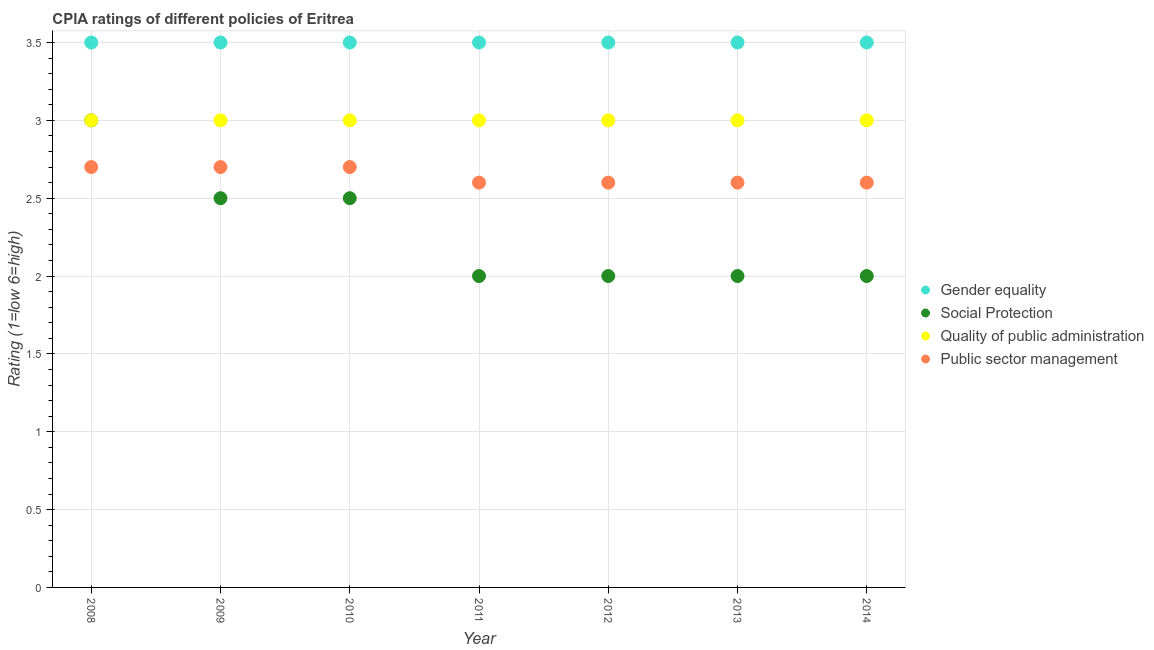How many different coloured dotlines are there?
Give a very brief answer. 4. Across all years, what is the minimum cpia rating of gender equality?
Provide a short and direct response. 3.5. In which year was the cpia rating of gender equality minimum?
Keep it short and to the point. 2008. What is the difference between the cpia rating of quality of public administration in 2013 and that in 2014?
Make the answer very short. 0. What is the average cpia rating of social protection per year?
Keep it short and to the point. 2.29. In the year 2014, what is the difference between the cpia rating of public sector management and cpia rating of social protection?
Provide a short and direct response. 0.6. What is the ratio of the cpia rating of quality of public administration in 2008 to that in 2014?
Offer a terse response. 1. Is the cpia rating of quality of public administration in 2011 less than that in 2013?
Ensure brevity in your answer.  No. Is the difference between the cpia rating of public sector management in 2013 and 2014 greater than the difference between the cpia rating of gender equality in 2013 and 2014?
Give a very brief answer. No. What is the difference between the highest and the lowest cpia rating of public sector management?
Offer a very short reply. 0.1. Is the sum of the cpia rating of quality of public administration in 2009 and 2013 greater than the maximum cpia rating of public sector management across all years?
Make the answer very short. Yes. Is it the case that in every year, the sum of the cpia rating of gender equality and cpia rating of public sector management is greater than the sum of cpia rating of quality of public administration and cpia rating of social protection?
Keep it short and to the point. No. Does the cpia rating of social protection monotonically increase over the years?
Your response must be concise. No. Is the cpia rating of social protection strictly less than the cpia rating of public sector management over the years?
Offer a terse response. No. How many dotlines are there?
Offer a terse response. 4. How many years are there in the graph?
Keep it short and to the point. 7. Are the values on the major ticks of Y-axis written in scientific E-notation?
Provide a succinct answer. No. Does the graph contain grids?
Keep it short and to the point. Yes. What is the title of the graph?
Make the answer very short. CPIA ratings of different policies of Eritrea. Does "Third 20% of population" appear as one of the legend labels in the graph?
Your answer should be compact. No. What is the Rating (1=low 6=high) of Social Protection in 2008?
Offer a very short reply. 3. What is the Rating (1=low 6=high) of Public sector management in 2008?
Keep it short and to the point. 2.7. What is the Rating (1=low 6=high) of Gender equality in 2009?
Your response must be concise. 3.5. What is the Rating (1=low 6=high) in Social Protection in 2010?
Give a very brief answer. 2.5. What is the Rating (1=low 6=high) in Quality of public administration in 2010?
Give a very brief answer. 3. What is the Rating (1=low 6=high) of Public sector management in 2010?
Make the answer very short. 2.7. What is the Rating (1=low 6=high) of Social Protection in 2011?
Make the answer very short. 2. What is the Rating (1=low 6=high) of Quality of public administration in 2011?
Keep it short and to the point. 3. What is the Rating (1=low 6=high) in Public sector management in 2011?
Make the answer very short. 2.6. What is the Rating (1=low 6=high) of Gender equality in 2012?
Give a very brief answer. 3.5. What is the Rating (1=low 6=high) in Public sector management in 2012?
Keep it short and to the point. 2.6. What is the Rating (1=low 6=high) of Gender equality in 2013?
Your answer should be compact. 3.5. What is the Rating (1=low 6=high) of Public sector management in 2014?
Offer a terse response. 2.6. Across all years, what is the maximum Rating (1=low 6=high) of Social Protection?
Your answer should be compact. 3. Across all years, what is the maximum Rating (1=low 6=high) in Quality of public administration?
Your answer should be compact. 3. Across all years, what is the maximum Rating (1=low 6=high) in Public sector management?
Make the answer very short. 2.7. Across all years, what is the minimum Rating (1=low 6=high) in Gender equality?
Offer a very short reply. 3.5. What is the difference between the Rating (1=low 6=high) in Gender equality in 2008 and that in 2009?
Ensure brevity in your answer.  0. What is the difference between the Rating (1=low 6=high) in Social Protection in 2008 and that in 2010?
Your response must be concise. 0.5. What is the difference between the Rating (1=low 6=high) in Public sector management in 2008 and that in 2010?
Your response must be concise. 0. What is the difference between the Rating (1=low 6=high) in Social Protection in 2008 and that in 2011?
Ensure brevity in your answer.  1. What is the difference between the Rating (1=low 6=high) in Quality of public administration in 2008 and that in 2012?
Offer a very short reply. 0. What is the difference between the Rating (1=low 6=high) of Gender equality in 2008 and that in 2013?
Ensure brevity in your answer.  0. What is the difference between the Rating (1=low 6=high) in Gender equality in 2008 and that in 2014?
Offer a terse response. 0. What is the difference between the Rating (1=low 6=high) in Social Protection in 2008 and that in 2014?
Give a very brief answer. 1. What is the difference between the Rating (1=low 6=high) in Quality of public administration in 2008 and that in 2014?
Give a very brief answer. 0. What is the difference between the Rating (1=low 6=high) of Public sector management in 2008 and that in 2014?
Keep it short and to the point. 0.1. What is the difference between the Rating (1=low 6=high) of Gender equality in 2009 and that in 2010?
Offer a terse response. 0. What is the difference between the Rating (1=low 6=high) in Social Protection in 2009 and that in 2010?
Your answer should be very brief. 0. What is the difference between the Rating (1=low 6=high) of Gender equality in 2009 and that in 2011?
Ensure brevity in your answer.  0. What is the difference between the Rating (1=low 6=high) of Social Protection in 2009 and that in 2011?
Make the answer very short. 0.5. What is the difference between the Rating (1=low 6=high) in Quality of public administration in 2009 and that in 2011?
Your response must be concise. 0. What is the difference between the Rating (1=low 6=high) in Gender equality in 2009 and that in 2012?
Give a very brief answer. 0. What is the difference between the Rating (1=low 6=high) of Social Protection in 2009 and that in 2012?
Offer a very short reply. 0.5. What is the difference between the Rating (1=low 6=high) in Social Protection in 2009 and that in 2013?
Make the answer very short. 0.5. What is the difference between the Rating (1=low 6=high) of Quality of public administration in 2009 and that in 2013?
Offer a terse response. 0. What is the difference between the Rating (1=low 6=high) of Public sector management in 2009 and that in 2013?
Ensure brevity in your answer.  0.1. What is the difference between the Rating (1=low 6=high) in Public sector management in 2009 and that in 2014?
Provide a succinct answer. 0.1. What is the difference between the Rating (1=low 6=high) of Quality of public administration in 2010 and that in 2011?
Offer a very short reply. 0. What is the difference between the Rating (1=low 6=high) in Public sector management in 2010 and that in 2011?
Your answer should be very brief. 0.1. What is the difference between the Rating (1=low 6=high) of Gender equality in 2010 and that in 2012?
Make the answer very short. 0. What is the difference between the Rating (1=low 6=high) in Public sector management in 2010 and that in 2012?
Offer a terse response. 0.1. What is the difference between the Rating (1=low 6=high) of Gender equality in 2010 and that in 2013?
Ensure brevity in your answer.  0. What is the difference between the Rating (1=low 6=high) in Social Protection in 2010 and that in 2014?
Provide a succinct answer. 0.5. What is the difference between the Rating (1=low 6=high) in Quality of public administration in 2010 and that in 2014?
Provide a succinct answer. 0. What is the difference between the Rating (1=low 6=high) in Quality of public administration in 2011 and that in 2012?
Offer a terse response. 0. What is the difference between the Rating (1=low 6=high) in Public sector management in 2011 and that in 2012?
Your answer should be compact. 0. What is the difference between the Rating (1=low 6=high) of Quality of public administration in 2011 and that in 2014?
Your answer should be very brief. 0. What is the difference between the Rating (1=low 6=high) of Public sector management in 2011 and that in 2014?
Make the answer very short. 0. What is the difference between the Rating (1=low 6=high) of Gender equality in 2012 and that in 2013?
Give a very brief answer. 0. What is the difference between the Rating (1=low 6=high) of Social Protection in 2012 and that in 2013?
Keep it short and to the point. 0. What is the difference between the Rating (1=low 6=high) of Public sector management in 2012 and that in 2013?
Provide a short and direct response. 0. What is the difference between the Rating (1=low 6=high) of Gender equality in 2012 and that in 2014?
Your answer should be very brief. 0. What is the difference between the Rating (1=low 6=high) in Public sector management in 2012 and that in 2014?
Offer a terse response. 0. What is the difference between the Rating (1=low 6=high) in Gender equality in 2013 and that in 2014?
Keep it short and to the point. 0. What is the difference between the Rating (1=low 6=high) in Quality of public administration in 2013 and that in 2014?
Keep it short and to the point. 0. What is the difference between the Rating (1=low 6=high) of Gender equality in 2008 and the Rating (1=low 6=high) of Social Protection in 2009?
Your answer should be compact. 1. What is the difference between the Rating (1=low 6=high) in Gender equality in 2008 and the Rating (1=low 6=high) in Quality of public administration in 2009?
Ensure brevity in your answer.  0.5. What is the difference between the Rating (1=low 6=high) of Gender equality in 2008 and the Rating (1=low 6=high) of Public sector management in 2009?
Your response must be concise. 0.8. What is the difference between the Rating (1=low 6=high) in Social Protection in 2008 and the Rating (1=low 6=high) in Quality of public administration in 2009?
Your answer should be very brief. 0. What is the difference between the Rating (1=low 6=high) in Gender equality in 2008 and the Rating (1=low 6=high) in Social Protection in 2010?
Keep it short and to the point. 1. What is the difference between the Rating (1=low 6=high) of Social Protection in 2008 and the Rating (1=low 6=high) of Quality of public administration in 2010?
Offer a very short reply. 0. What is the difference between the Rating (1=low 6=high) in Social Protection in 2008 and the Rating (1=low 6=high) in Public sector management in 2010?
Provide a succinct answer. 0.3. What is the difference between the Rating (1=low 6=high) in Gender equality in 2008 and the Rating (1=low 6=high) in Social Protection in 2011?
Your answer should be compact. 1.5. What is the difference between the Rating (1=low 6=high) in Social Protection in 2008 and the Rating (1=low 6=high) in Quality of public administration in 2011?
Ensure brevity in your answer.  0. What is the difference between the Rating (1=low 6=high) of Gender equality in 2008 and the Rating (1=low 6=high) of Quality of public administration in 2012?
Provide a short and direct response. 0.5. What is the difference between the Rating (1=low 6=high) in Gender equality in 2008 and the Rating (1=low 6=high) in Public sector management in 2012?
Ensure brevity in your answer.  0.9. What is the difference between the Rating (1=low 6=high) in Social Protection in 2008 and the Rating (1=low 6=high) in Quality of public administration in 2012?
Keep it short and to the point. 0. What is the difference between the Rating (1=low 6=high) in Gender equality in 2008 and the Rating (1=low 6=high) in Public sector management in 2013?
Your answer should be very brief. 0.9. What is the difference between the Rating (1=low 6=high) in Social Protection in 2008 and the Rating (1=low 6=high) in Quality of public administration in 2013?
Provide a short and direct response. 0. What is the difference between the Rating (1=low 6=high) of Quality of public administration in 2008 and the Rating (1=low 6=high) of Public sector management in 2013?
Provide a short and direct response. 0.4. What is the difference between the Rating (1=low 6=high) of Gender equality in 2008 and the Rating (1=low 6=high) of Social Protection in 2014?
Provide a short and direct response. 1.5. What is the difference between the Rating (1=low 6=high) in Social Protection in 2008 and the Rating (1=low 6=high) in Public sector management in 2014?
Provide a succinct answer. 0.4. What is the difference between the Rating (1=low 6=high) of Gender equality in 2009 and the Rating (1=low 6=high) of Quality of public administration in 2010?
Offer a terse response. 0.5. What is the difference between the Rating (1=low 6=high) of Gender equality in 2009 and the Rating (1=low 6=high) of Public sector management in 2010?
Your response must be concise. 0.8. What is the difference between the Rating (1=low 6=high) in Social Protection in 2009 and the Rating (1=low 6=high) in Quality of public administration in 2010?
Offer a very short reply. -0.5. What is the difference between the Rating (1=low 6=high) of Social Protection in 2009 and the Rating (1=low 6=high) of Public sector management in 2010?
Offer a very short reply. -0.2. What is the difference between the Rating (1=low 6=high) of Quality of public administration in 2009 and the Rating (1=low 6=high) of Public sector management in 2010?
Your answer should be compact. 0.3. What is the difference between the Rating (1=low 6=high) in Gender equality in 2009 and the Rating (1=low 6=high) in Social Protection in 2011?
Your answer should be compact. 1.5. What is the difference between the Rating (1=low 6=high) of Social Protection in 2009 and the Rating (1=low 6=high) of Quality of public administration in 2011?
Your answer should be compact. -0.5. What is the difference between the Rating (1=low 6=high) in Social Protection in 2009 and the Rating (1=low 6=high) in Public sector management in 2011?
Your answer should be compact. -0.1. What is the difference between the Rating (1=low 6=high) in Gender equality in 2009 and the Rating (1=low 6=high) in Public sector management in 2012?
Your response must be concise. 0.9. What is the difference between the Rating (1=low 6=high) in Social Protection in 2009 and the Rating (1=low 6=high) in Public sector management in 2012?
Offer a very short reply. -0.1. What is the difference between the Rating (1=low 6=high) in Gender equality in 2009 and the Rating (1=low 6=high) in Public sector management in 2013?
Your response must be concise. 0.9. What is the difference between the Rating (1=low 6=high) in Social Protection in 2009 and the Rating (1=low 6=high) in Public sector management in 2013?
Offer a terse response. -0.1. What is the difference between the Rating (1=low 6=high) in Gender equality in 2009 and the Rating (1=low 6=high) in Quality of public administration in 2014?
Your answer should be compact. 0.5. What is the difference between the Rating (1=low 6=high) of Social Protection in 2009 and the Rating (1=low 6=high) of Quality of public administration in 2014?
Keep it short and to the point. -0.5. What is the difference between the Rating (1=low 6=high) in Social Protection in 2009 and the Rating (1=low 6=high) in Public sector management in 2014?
Offer a terse response. -0.1. What is the difference between the Rating (1=low 6=high) in Gender equality in 2010 and the Rating (1=low 6=high) in Social Protection in 2011?
Give a very brief answer. 1.5. What is the difference between the Rating (1=low 6=high) of Social Protection in 2010 and the Rating (1=low 6=high) of Quality of public administration in 2011?
Keep it short and to the point. -0.5. What is the difference between the Rating (1=low 6=high) of Social Protection in 2010 and the Rating (1=low 6=high) of Quality of public administration in 2012?
Ensure brevity in your answer.  -0.5. What is the difference between the Rating (1=low 6=high) of Quality of public administration in 2010 and the Rating (1=low 6=high) of Public sector management in 2012?
Keep it short and to the point. 0.4. What is the difference between the Rating (1=low 6=high) of Gender equality in 2010 and the Rating (1=low 6=high) of Public sector management in 2013?
Your answer should be very brief. 0.9. What is the difference between the Rating (1=low 6=high) of Quality of public administration in 2010 and the Rating (1=low 6=high) of Public sector management in 2013?
Provide a short and direct response. 0.4. What is the difference between the Rating (1=low 6=high) of Gender equality in 2010 and the Rating (1=low 6=high) of Social Protection in 2014?
Your answer should be compact. 1.5. What is the difference between the Rating (1=low 6=high) of Gender equality in 2010 and the Rating (1=low 6=high) of Public sector management in 2014?
Provide a succinct answer. 0.9. What is the difference between the Rating (1=low 6=high) in Gender equality in 2011 and the Rating (1=low 6=high) in Social Protection in 2012?
Keep it short and to the point. 1.5. What is the difference between the Rating (1=low 6=high) in Gender equality in 2011 and the Rating (1=low 6=high) in Quality of public administration in 2012?
Provide a succinct answer. 0.5. What is the difference between the Rating (1=low 6=high) of Gender equality in 2011 and the Rating (1=low 6=high) of Public sector management in 2012?
Offer a very short reply. 0.9. What is the difference between the Rating (1=low 6=high) of Social Protection in 2011 and the Rating (1=low 6=high) of Quality of public administration in 2012?
Your answer should be very brief. -1. What is the difference between the Rating (1=low 6=high) in Gender equality in 2011 and the Rating (1=low 6=high) in Social Protection in 2013?
Give a very brief answer. 1.5. What is the difference between the Rating (1=low 6=high) of Gender equality in 2011 and the Rating (1=low 6=high) of Quality of public administration in 2013?
Give a very brief answer. 0.5. What is the difference between the Rating (1=low 6=high) in Gender equality in 2011 and the Rating (1=low 6=high) in Public sector management in 2013?
Ensure brevity in your answer.  0.9. What is the difference between the Rating (1=low 6=high) of Social Protection in 2011 and the Rating (1=low 6=high) of Quality of public administration in 2013?
Your response must be concise. -1. What is the difference between the Rating (1=low 6=high) of Quality of public administration in 2011 and the Rating (1=low 6=high) of Public sector management in 2013?
Keep it short and to the point. 0.4. What is the difference between the Rating (1=low 6=high) in Gender equality in 2011 and the Rating (1=low 6=high) in Quality of public administration in 2014?
Provide a short and direct response. 0.5. What is the difference between the Rating (1=low 6=high) of Gender equality in 2011 and the Rating (1=low 6=high) of Public sector management in 2014?
Make the answer very short. 0.9. What is the difference between the Rating (1=low 6=high) of Social Protection in 2011 and the Rating (1=low 6=high) of Quality of public administration in 2014?
Ensure brevity in your answer.  -1. What is the difference between the Rating (1=low 6=high) in Gender equality in 2012 and the Rating (1=low 6=high) in Social Protection in 2013?
Provide a short and direct response. 1.5. What is the difference between the Rating (1=low 6=high) in Gender equality in 2012 and the Rating (1=low 6=high) in Quality of public administration in 2013?
Offer a terse response. 0.5. What is the difference between the Rating (1=low 6=high) in Social Protection in 2012 and the Rating (1=low 6=high) in Quality of public administration in 2013?
Give a very brief answer. -1. What is the difference between the Rating (1=low 6=high) in Gender equality in 2012 and the Rating (1=low 6=high) in Public sector management in 2014?
Offer a terse response. 0.9. What is the difference between the Rating (1=low 6=high) in Gender equality in 2013 and the Rating (1=low 6=high) in Social Protection in 2014?
Offer a very short reply. 1.5. What is the difference between the Rating (1=low 6=high) of Gender equality in 2013 and the Rating (1=low 6=high) of Public sector management in 2014?
Your answer should be compact. 0.9. What is the difference between the Rating (1=low 6=high) of Social Protection in 2013 and the Rating (1=low 6=high) of Quality of public administration in 2014?
Your response must be concise. -1. What is the difference between the Rating (1=low 6=high) in Social Protection in 2013 and the Rating (1=low 6=high) in Public sector management in 2014?
Ensure brevity in your answer.  -0.6. What is the average Rating (1=low 6=high) in Gender equality per year?
Make the answer very short. 3.5. What is the average Rating (1=low 6=high) in Social Protection per year?
Provide a short and direct response. 2.29. What is the average Rating (1=low 6=high) in Public sector management per year?
Make the answer very short. 2.64. In the year 2008, what is the difference between the Rating (1=low 6=high) of Gender equality and Rating (1=low 6=high) of Quality of public administration?
Offer a very short reply. 0.5. In the year 2008, what is the difference between the Rating (1=low 6=high) of Social Protection and Rating (1=low 6=high) of Public sector management?
Your response must be concise. 0.3. In the year 2009, what is the difference between the Rating (1=low 6=high) in Social Protection and Rating (1=low 6=high) in Quality of public administration?
Provide a succinct answer. -0.5. In the year 2010, what is the difference between the Rating (1=low 6=high) of Gender equality and Rating (1=low 6=high) of Quality of public administration?
Your answer should be compact. 0.5. In the year 2010, what is the difference between the Rating (1=low 6=high) of Gender equality and Rating (1=low 6=high) of Public sector management?
Provide a succinct answer. 0.8. In the year 2010, what is the difference between the Rating (1=low 6=high) in Quality of public administration and Rating (1=low 6=high) in Public sector management?
Make the answer very short. 0.3. In the year 2011, what is the difference between the Rating (1=low 6=high) of Social Protection and Rating (1=low 6=high) of Public sector management?
Keep it short and to the point. -0.6. In the year 2011, what is the difference between the Rating (1=low 6=high) in Quality of public administration and Rating (1=low 6=high) in Public sector management?
Offer a very short reply. 0.4. In the year 2012, what is the difference between the Rating (1=low 6=high) of Gender equality and Rating (1=low 6=high) of Quality of public administration?
Keep it short and to the point. 0.5. In the year 2012, what is the difference between the Rating (1=low 6=high) in Social Protection and Rating (1=low 6=high) in Public sector management?
Offer a terse response. -0.6. In the year 2013, what is the difference between the Rating (1=low 6=high) in Gender equality and Rating (1=low 6=high) in Social Protection?
Keep it short and to the point. 1.5. In the year 2013, what is the difference between the Rating (1=low 6=high) in Gender equality and Rating (1=low 6=high) in Public sector management?
Make the answer very short. 0.9. In the year 2013, what is the difference between the Rating (1=low 6=high) in Social Protection and Rating (1=low 6=high) in Quality of public administration?
Your answer should be very brief. -1. In the year 2013, what is the difference between the Rating (1=low 6=high) in Quality of public administration and Rating (1=low 6=high) in Public sector management?
Make the answer very short. 0.4. In the year 2014, what is the difference between the Rating (1=low 6=high) of Gender equality and Rating (1=low 6=high) of Social Protection?
Provide a short and direct response. 1.5. In the year 2014, what is the difference between the Rating (1=low 6=high) of Quality of public administration and Rating (1=low 6=high) of Public sector management?
Give a very brief answer. 0.4. What is the ratio of the Rating (1=low 6=high) of Social Protection in 2008 to that in 2009?
Give a very brief answer. 1.2. What is the ratio of the Rating (1=low 6=high) in Gender equality in 2008 to that in 2010?
Offer a very short reply. 1. What is the ratio of the Rating (1=low 6=high) in Quality of public administration in 2008 to that in 2010?
Offer a terse response. 1. What is the ratio of the Rating (1=low 6=high) in Public sector management in 2008 to that in 2010?
Give a very brief answer. 1. What is the ratio of the Rating (1=low 6=high) in Gender equality in 2008 to that in 2011?
Ensure brevity in your answer.  1. What is the ratio of the Rating (1=low 6=high) in Quality of public administration in 2008 to that in 2011?
Give a very brief answer. 1. What is the ratio of the Rating (1=low 6=high) in Quality of public administration in 2008 to that in 2012?
Ensure brevity in your answer.  1. What is the ratio of the Rating (1=low 6=high) in Gender equality in 2008 to that in 2014?
Keep it short and to the point. 1. What is the ratio of the Rating (1=low 6=high) in Social Protection in 2008 to that in 2014?
Make the answer very short. 1.5. What is the ratio of the Rating (1=low 6=high) of Public sector management in 2008 to that in 2014?
Provide a succinct answer. 1.04. What is the ratio of the Rating (1=low 6=high) of Social Protection in 2009 to that in 2010?
Your answer should be very brief. 1. What is the ratio of the Rating (1=low 6=high) of Gender equality in 2009 to that in 2011?
Provide a succinct answer. 1. What is the ratio of the Rating (1=low 6=high) of Quality of public administration in 2009 to that in 2011?
Offer a terse response. 1. What is the ratio of the Rating (1=low 6=high) of Gender equality in 2009 to that in 2012?
Keep it short and to the point. 1. What is the ratio of the Rating (1=low 6=high) in Public sector management in 2009 to that in 2012?
Your response must be concise. 1.04. What is the ratio of the Rating (1=low 6=high) of Social Protection in 2009 to that in 2013?
Your response must be concise. 1.25. What is the ratio of the Rating (1=low 6=high) of Quality of public administration in 2009 to that in 2014?
Provide a succinct answer. 1. What is the ratio of the Rating (1=low 6=high) in Public sector management in 2009 to that in 2014?
Make the answer very short. 1.04. What is the ratio of the Rating (1=low 6=high) in Social Protection in 2010 to that in 2011?
Make the answer very short. 1.25. What is the ratio of the Rating (1=low 6=high) of Quality of public administration in 2010 to that in 2011?
Ensure brevity in your answer.  1. What is the ratio of the Rating (1=low 6=high) of Public sector management in 2010 to that in 2011?
Provide a short and direct response. 1.04. What is the ratio of the Rating (1=low 6=high) of Social Protection in 2010 to that in 2012?
Ensure brevity in your answer.  1.25. What is the ratio of the Rating (1=low 6=high) of Public sector management in 2010 to that in 2012?
Keep it short and to the point. 1.04. What is the ratio of the Rating (1=low 6=high) of Social Protection in 2010 to that in 2013?
Ensure brevity in your answer.  1.25. What is the ratio of the Rating (1=low 6=high) of Quality of public administration in 2010 to that in 2013?
Your answer should be very brief. 1. What is the ratio of the Rating (1=low 6=high) in Quality of public administration in 2010 to that in 2014?
Your answer should be compact. 1. What is the ratio of the Rating (1=low 6=high) in Public sector management in 2010 to that in 2014?
Your answer should be very brief. 1.04. What is the ratio of the Rating (1=low 6=high) of Social Protection in 2011 to that in 2012?
Your answer should be very brief. 1. What is the ratio of the Rating (1=low 6=high) of Quality of public administration in 2011 to that in 2012?
Give a very brief answer. 1. What is the ratio of the Rating (1=low 6=high) in Public sector management in 2011 to that in 2012?
Keep it short and to the point. 1. What is the ratio of the Rating (1=low 6=high) of Social Protection in 2011 to that in 2013?
Make the answer very short. 1. What is the ratio of the Rating (1=low 6=high) of Public sector management in 2011 to that in 2013?
Provide a succinct answer. 1. What is the ratio of the Rating (1=low 6=high) in Social Protection in 2011 to that in 2014?
Ensure brevity in your answer.  1. What is the ratio of the Rating (1=low 6=high) of Gender equality in 2012 to that in 2013?
Provide a short and direct response. 1. What is the ratio of the Rating (1=low 6=high) of Social Protection in 2012 to that in 2014?
Your response must be concise. 1. What is the ratio of the Rating (1=low 6=high) of Quality of public administration in 2012 to that in 2014?
Give a very brief answer. 1. What is the ratio of the Rating (1=low 6=high) of Public sector management in 2012 to that in 2014?
Make the answer very short. 1. What is the ratio of the Rating (1=low 6=high) of Social Protection in 2013 to that in 2014?
Provide a succinct answer. 1. What is the ratio of the Rating (1=low 6=high) in Public sector management in 2013 to that in 2014?
Your response must be concise. 1. What is the difference between the highest and the second highest Rating (1=low 6=high) in Public sector management?
Your response must be concise. 0. What is the difference between the highest and the lowest Rating (1=low 6=high) of Social Protection?
Your response must be concise. 1. What is the difference between the highest and the lowest Rating (1=low 6=high) of Quality of public administration?
Offer a terse response. 0. 